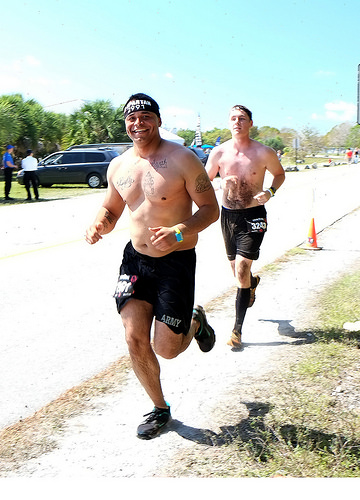<image>
Is there a man one next to the man two? No. The man one is not positioned next to the man two. They are located in different areas of the scene. 